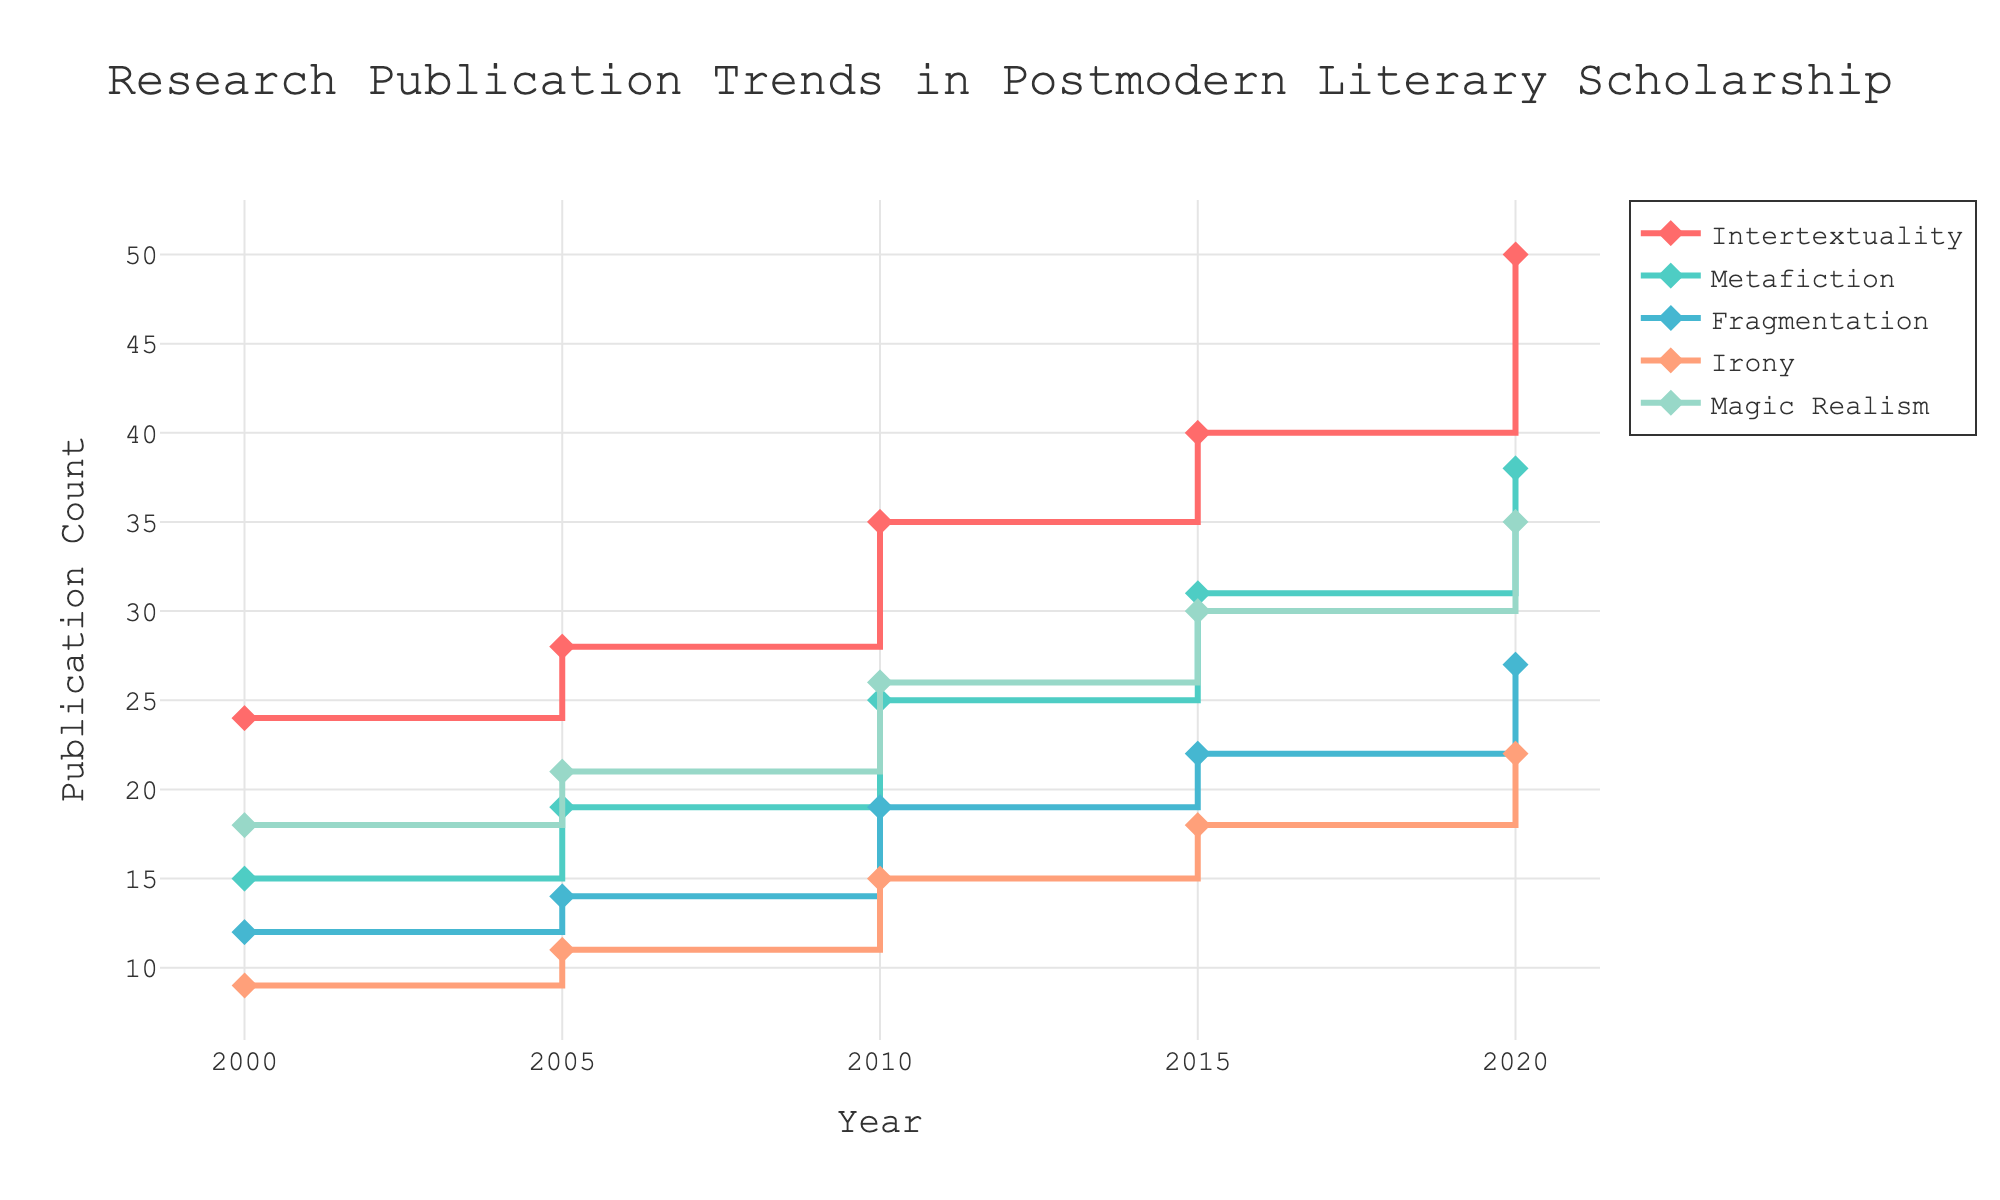What is the title of the figure? The title of the figure is displayed at the top center of the plot. It provides an overview of the content being visualized.
Answer: Research Publication Trends in Postmodern Literary Scholarship How many thematic areas are being tracked over the years? The thematic areas are represented by different lines in the figure, with each line corresponding to a unique theme. Counting the lines or the legend entries gives the number of thematic areas.
Answer: 5 Which theme had the highest publication count in 2020? By looking at the end points of each line in the year 2020 on the x-axis, the theme with the highest y-value represents the highest publication count.
Answer: Intertextuality What was the publication count for "Irony" in 2015? Locate the year 2015 on the x-axis and follow the "Irony" line (which can be identified from the legend) to find the corresponding y-value.
Answer: 18 What is the overall trend for "Magic Realism" from 2000 to 2020? By observing the "Magic Realism" line, examine the general direction of the line from the year 2000 to 2020.
Answer: Increasing How did the publication counts for "Fragmentation" change between 2010 and 2015? Identify the y-values for "Fragmentation" in 2010 and 2015 and calculate the difference to understand the change.
Answer: Increased by 3 Which theme shows the most consistent growth over the years? By comparing the slopes and directions of each thematic line, determine which one shows a steady increase without significant fluctuations.
Answer: Intertextuality What was the total publication count for all themes in the year 2010? Sum the publication counts for all thematic areas in the year 2010 by adding the y-values at 2010 for each theme.
Answer: 120 Between which consecutive years did "Metafiction" see the highest increase in publication count? Calculate the difference in publication counts for "Metafiction" between each pair of consecutive years: 2000-2005, 2005-2010, 2010-2015, and 2015-2020, and identify the highest difference.
Answer: 2015-2020 Which thematic area had the least number of publications in 2000? Locate the year 2000 on the x-axis and compare the y-values of all thematic lines to find the lowest point.
Answer: Irony 